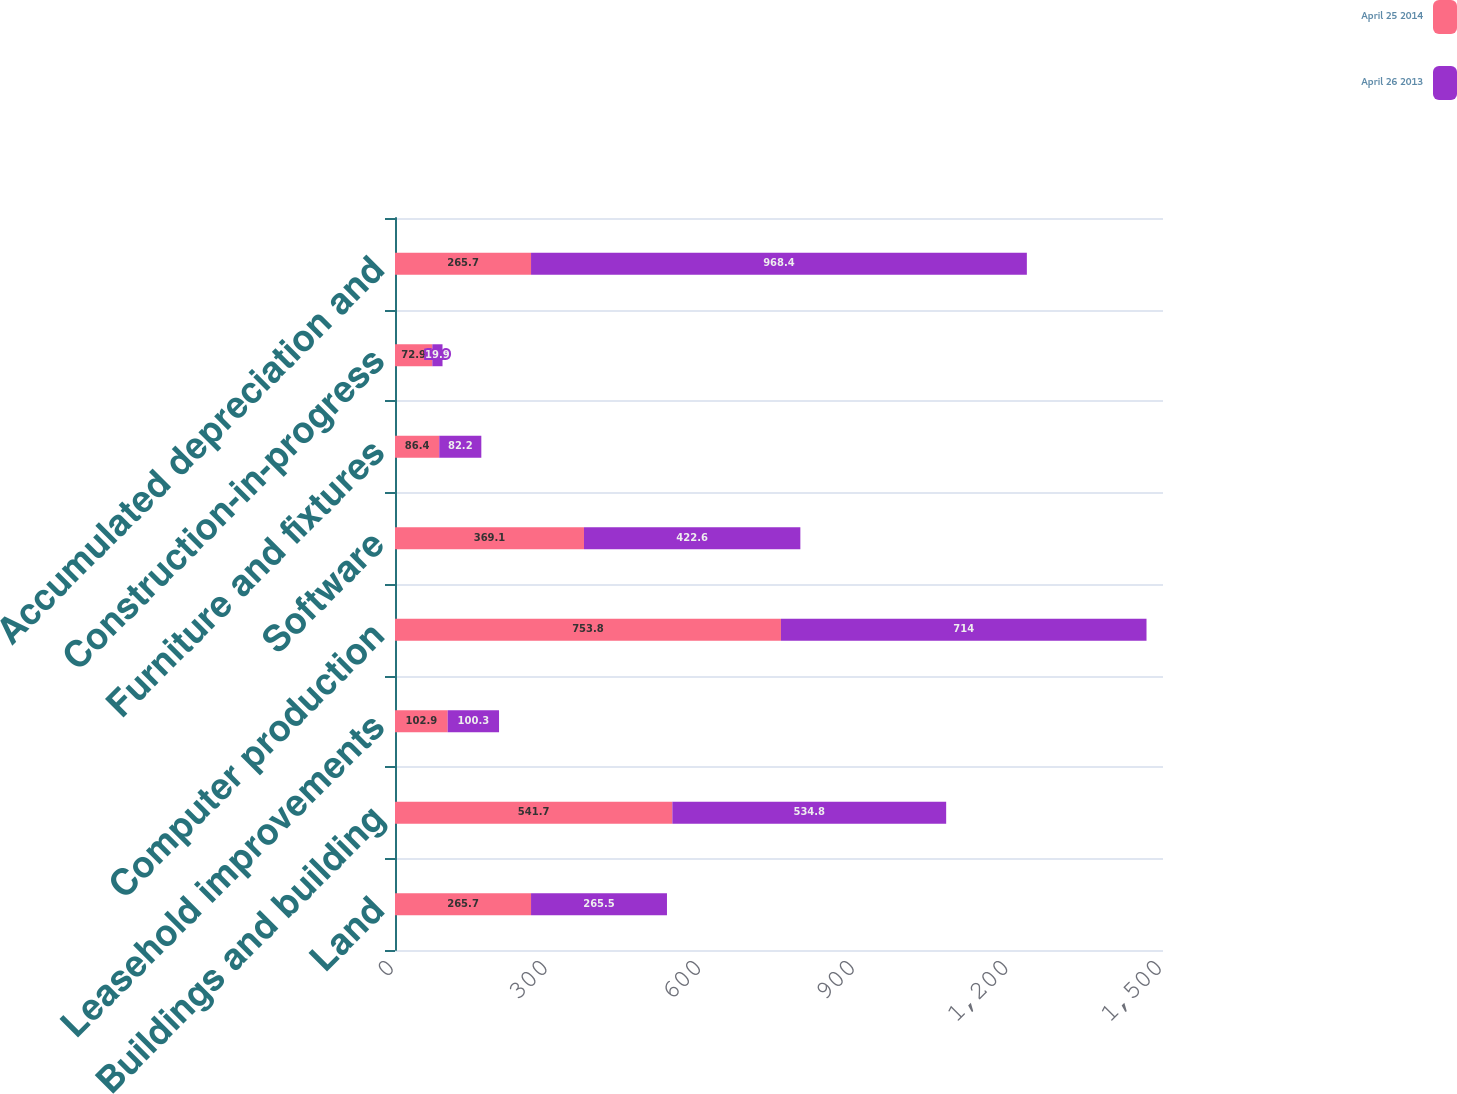<chart> <loc_0><loc_0><loc_500><loc_500><stacked_bar_chart><ecel><fcel>Land<fcel>Buildings and building<fcel>Leasehold improvements<fcel>Computer production<fcel>Software<fcel>Furniture and fixtures<fcel>Construction-in-progress<fcel>Accumulated depreciation and<nl><fcel>April 25 2014<fcel>265.7<fcel>541.7<fcel>102.9<fcel>753.8<fcel>369.1<fcel>86.4<fcel>72.9<fcel>265.7<nl><fcel>April 26 2013<fcel>265.5<fcel>534.8<fcel>100.3<fcel>714<fcel>422.6<fcel>82.2<fcel>19.9<fcel>968.4<nl></chart> 